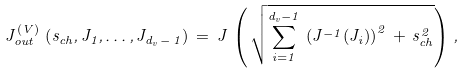<formula> <loc_0><loc_0><loc_500><loc_500>J _ { o u t } ^ { ( V ) } \, \left ( s _ { c h } , J _ { 1 } , \dots , J _ { d _ { v } \, - \, 1 } \right ) \, = \, J \, \left ( \, \sqrt { \sum _ { i = 1 } ^ { d _ { v } - 1 } \, \left ( J ^ { - 1 } ( J _ { i } ) \right ) ^ { 2 } \, + \, s _ { c h } ^ { 2 } } \right ) \, ,</formula> 